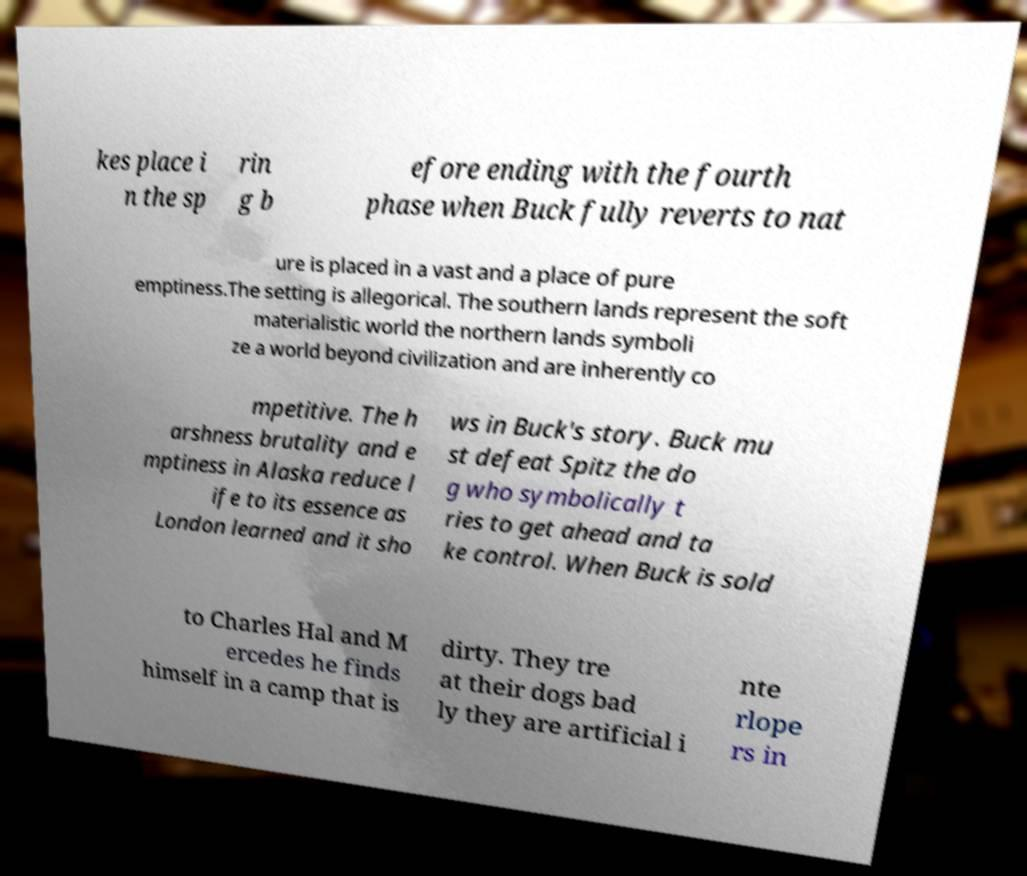Could you assist in decoding the text presented in this image and type it out clearly? kes place i n the sp rin g b efore ending with the fourth phase when Buck fully reverts to nat ure is placed in a vast and a place of pure emptiness.The setting is allegorical. The southern lands represent the soft materialistic world the northern lands symboli ze a world beyond civilization and are inherently co mpetitive. The h arshness brutality and e mptiness in Alaska reduce l ife to its essence as London learned and it sho ws in Buck's story. Buck mu st defeat Spitz the do g who symbolically t ries to get ahead and ta ke control. When Buck is sold to Charles Hal and M ercedes he finds himself in a camp that is dirty. They tre at their dogs bad ly they are artificial i nte rlope rs in 